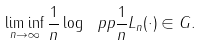Convert formula to latex. <formula><loc_0><loc_0><loc_500><loc_500>\liminf _ { n \to \infty } \frac { 1 } { n } \log { \ p p { \frac { 1 } { n } L _ { n } ( \cdot ) \in G } } .</formula> 